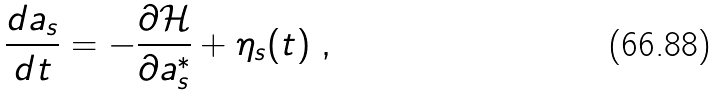<formula> <loc_0><loc_0><loc_500><loc_500>\frac { d a _ { s } } { d t } = - \frac { \partial \mathcal { H } } { \partial a ^ { * } _ { s } } + \eta _ { s } ( t ) \ ,</formula> 